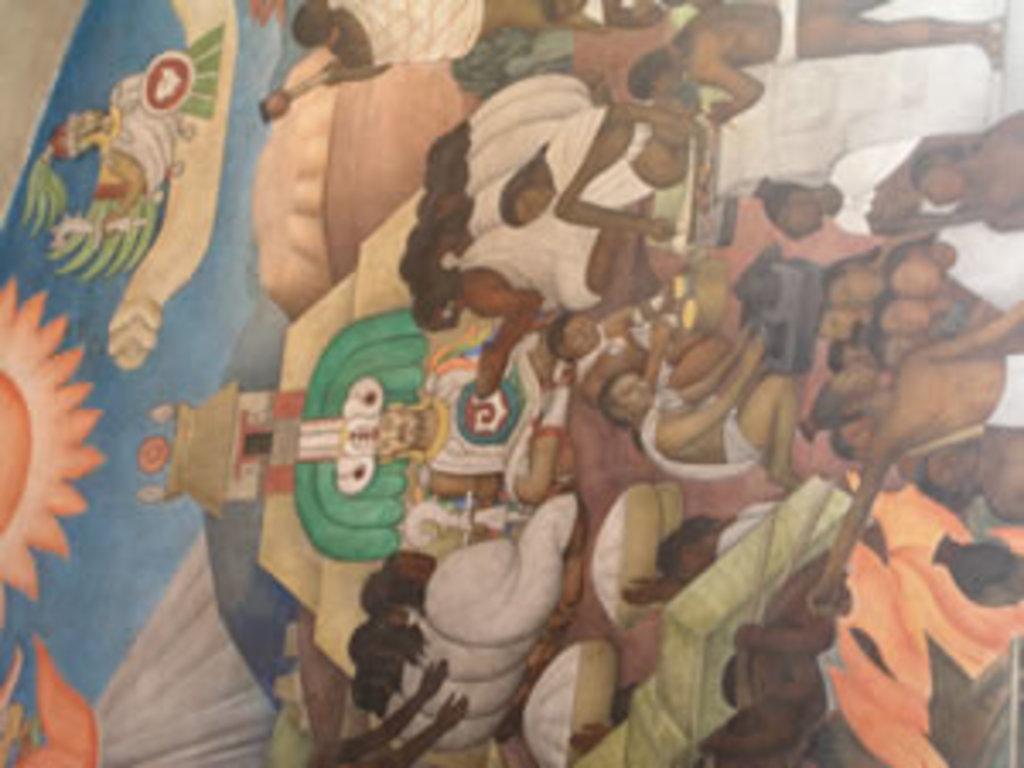Describe this image in one or two sentences. In this image we can see a painting and in this we can see the depictions of people. 